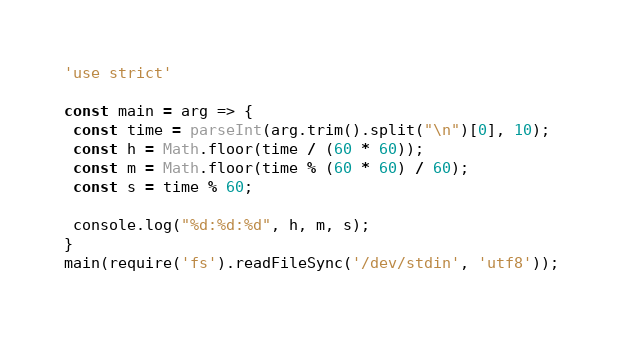<code> <loc_0><loc_0><loc_500><loc_500><_JavaScript_>'use strict'

const main = arg => {
 const time = parseInt(arg.trim().split("\n")[0], 10);
 const h = Math.floor(time / (60 * 60));
 const m = Math.floor(time % (60 * 60) / 60);
 const s = time % 60;

 console.log("%d:%d:%d", h, m, s);
}
main(require('fs').readFileSync('/dev/stdin', 'utf8'));


</code> 